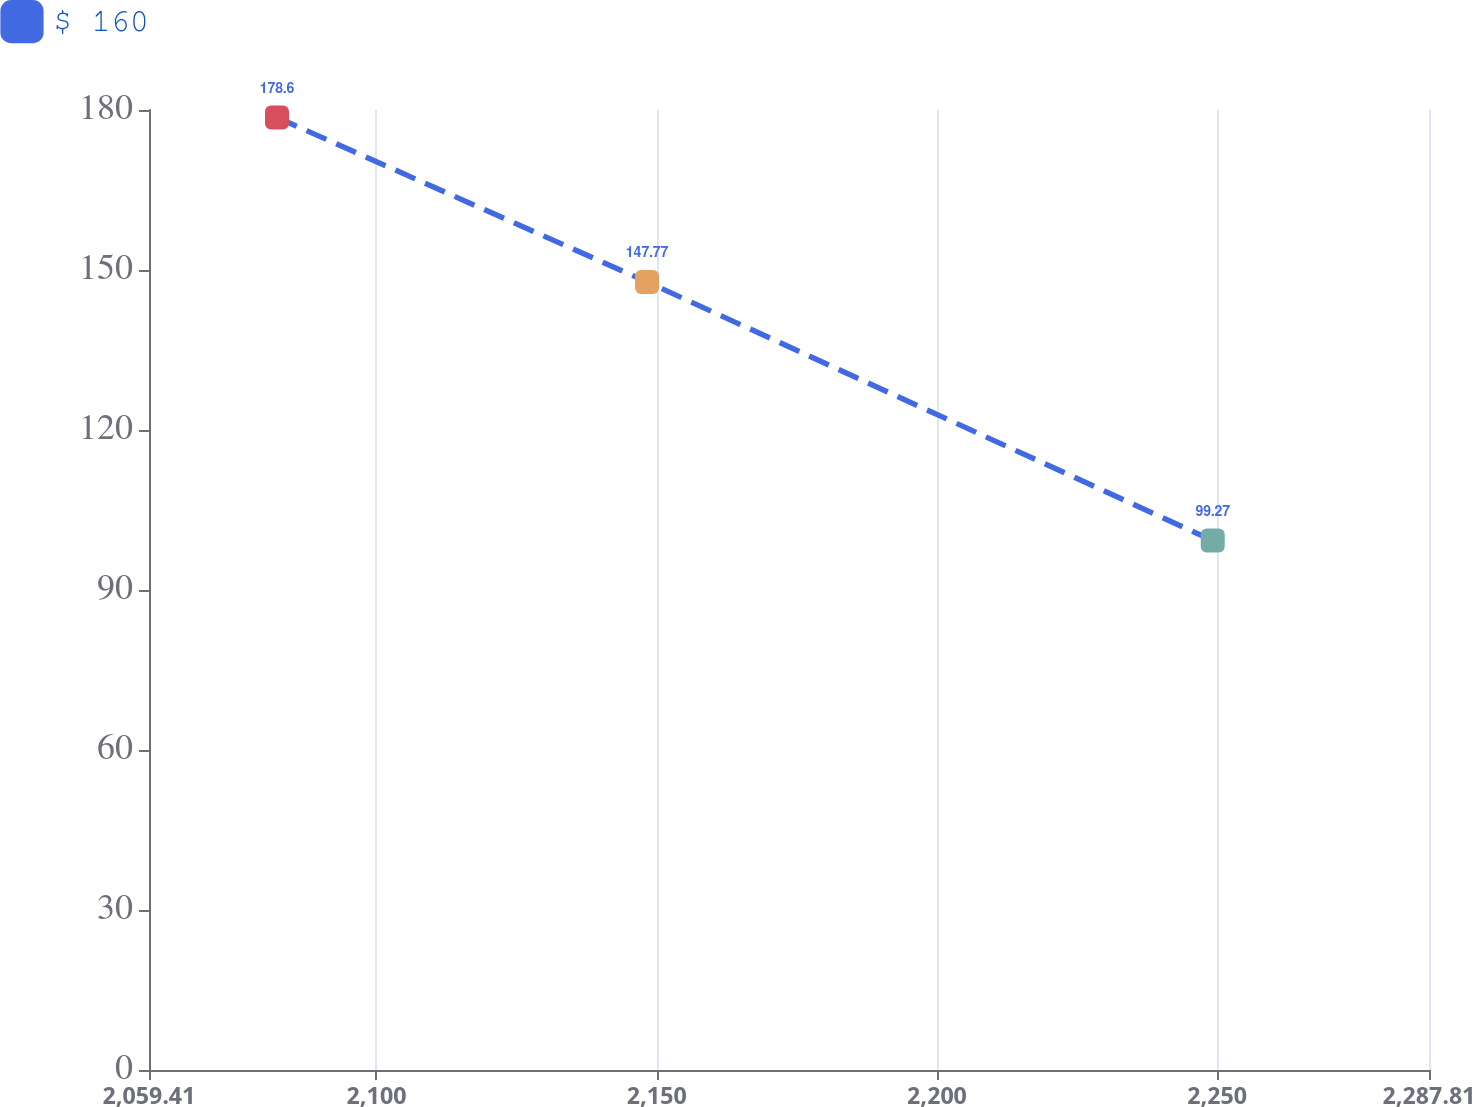Convert chart to OTSL. <chart><loc_0><loc_0><loc_500><loc_500><line_chart><ecel><fcel>$ 160<nl><fcel>2082.25<fcel>178.6<nl><fcel>2148.28<fcel>147.77<nl><fcel>2249.22<fcel>99.27<nl><fcel>2310.65<fcel>89.05<nl></chart> 